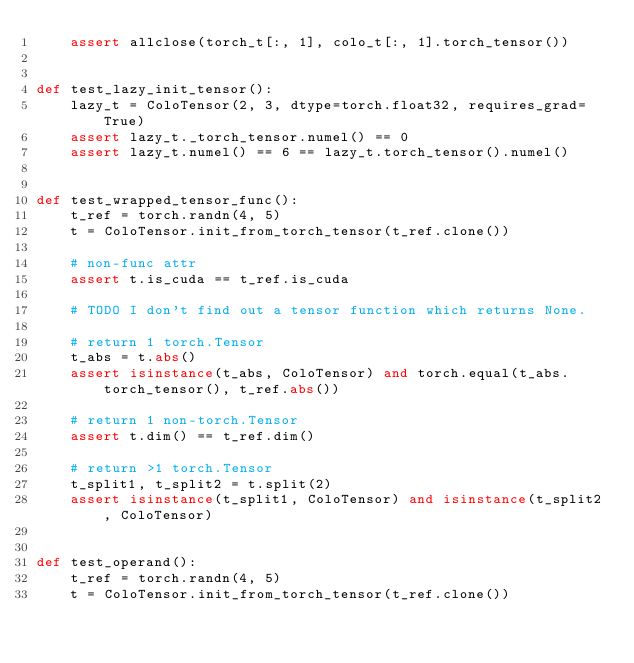<code> <loc_0><loc_0><loc_500><loc_500><_Python_>    assert allclose(torch_t[:, 1], colo_t[:, 1].torch_tensor())


def test_lazy_init_tensor():
    lazy_t = ColoTensor(2, 3, dtype=torch.float32, requires_grad=True)
    assert lazy_t._torch_tensor.numel() == 0
    assert lazy_t.numel() == 6 == lazy_t.torch_tensor().numel()


def test_wrapped_tensor_func():
    t_ref = torch.randn(4, 5)
    t = ColoTensor.init_from_torch_tensor(t_ref.clone())

    # non-func attr
    assert t.is_cuda == t_ref.is_cuda

    # TODO I don't find out a tensor function which returns None.

    # return 1 torch.Tensor
    t_abs = t.abs()
    assert isinstance(t_abs, ColoTensor) and torch.equal(t_abs.torch_tensor(), t_ref.abs())

    # return 1 non-torch.Tensor
    assert t.dim() == t_ref.dim()

    # return >1 torch.Tensor
    t_split1, t_split2 = t.split(2)
    assert isinstance(t_split1, ColoTensor) and isinstance(t_split2, ColoTensor)


def test_operand():
    t_ref = torch.randn(4, 5)
    t = ColoTensor.init_from_torch_tensor(t_ref.clone())
</code> 